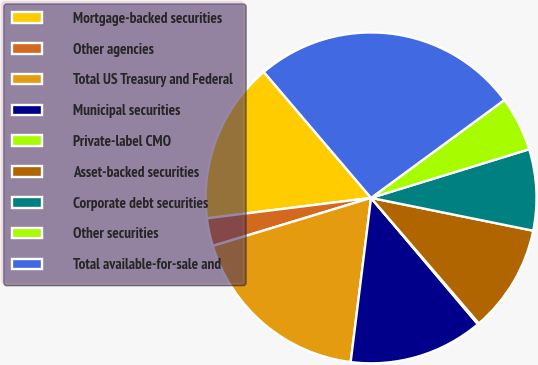Convert chart to OTSL. <chart><loc_0><loc_0><loc_500><loc_500><pie_chart><fcel>Mortgage-backed securities<fcel>Other agencies<fcel>Total US Treasury and Federal<fcel>Municipal securities<fcel>Private-label CMO<fcel>Asset-backed securities<fcel>Corporate debt securities<fcel>Other securities<fcel>Total available-for-sale and<nl><fcel>15.74%<fcel>2.72%<fcel>18.34%<fcel>13.14%<fcel>0.12%<fcel>10.53%<fcel>7.93%<fcel>5.33%<fcel>26.15%<nl></chart> 